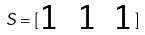<formula> <loc_0><loc_0><loc_500><loc_500>S = [ \begin{matrix} 1 & 1 & 1 \end{matrix} ]</formula> 